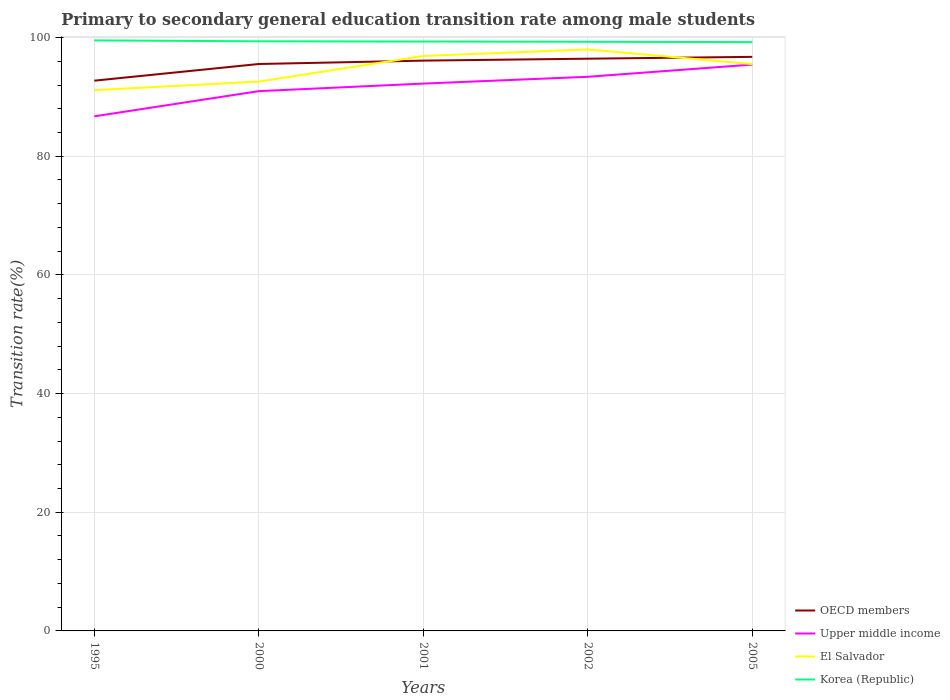How many different coloured lines are there?
Provide a succinct answer. 4. Does the line corresponding to Korea (Republic) intersect with the line corresponding to Upper middle income?
Ensure brevity in your answer.  No. Across all years, what is the maximum transition rate in OECD members?
Provide a short and direct response. 92.74. In which year was the transition rate in OECD members maximum?
Offer a terse response. 1995. What is the total transition rate in El Salvador in the graph?
Your answer should be compact. -5.42. What is the difference between the highest and the second highest transition rate in Korea (Republic)?
Offer a terse response. 0.29. What is the difference between two consecutive major ticks on the Y-axis?
Provide a short and direct response. 20. Are the values on the major ticks of Y-axis written in scientific E-notation?
Your answer should be very brief. No. Does the graph contain any zero values?
Keep it short and to the point. No. Does the graph contain grids?
Your response must be concise. Yes. Where does the legend appear in the graph?
Provide a succinct answer. Bottom right. How are the legend labels stacked?
Make the answer very short. Vertical. What is the title of the graph?
Ensure brevity in your answer.  Primary to secondary general education transition rate among male students. Does "Myanmar" appear as one of the legend labels in the graph?
Offer a very short reply. No. What is the label or title of the Y-axis?
Make the answer very short. Transition rate(%). What is the Transition rate(%) in OECD members in 1995?
Your response must be concise. 92.74. What is the Transition rate(%) of Upper middle income in 1995?
Your answer should be very brief. 86.73. What is the Transition rate(%) in El Salvador in 1995?
Keep it short and to the point. 91.15. What is the Transition rate(%) in Korea (Republic) in 1995?
Make the answer very short. 99.53. What is the Transition rate(%) in OECD members in 2000?
Offer a terse response. 95.55. What is the Transition rate(%) of Upper middle income in 2000?
Your answer should be compact. 90.97. What is the Transition rate(%) of El Salvador in 2000?
Give a very brief answer. 92.58. What is the Transition rate(%) of Korea (Republic) in 2000?
Make the answer very short. 99.37. What is the Transition rate(%) in OECD members in 2001?
Provide a short and direct response. 96.12. What is the Transition rate(%) of Upper middle income in 2001?
Ensure brevity in your answer.  92.25. What is the Transition rate(%) in El Salvador in 2001?
Offer a very short reply. 96.9. What is the Transition rate(%) of Korea (Republic) in 2001?
Make the answer very short. 99.33. What is the Transition rate(%) of OECD members in 2002?
Your answer should be compact. 96.44. What is the Transition rate(%) in Upper middle income in 2002?
Keep it short and to the point. 93.39. What is the Transition rate(%) in El Salvador in 2002?
Provide a succinct answer. 98. What is the Transition rate(%) of Korea (Republic) in 2002?
Provide a succinct answer. 99.3. What is the Transition rate(%) of OECD members in 2005?
Your answer should be compact. 96.75. What is the Transition rate(%) of Upper middle income in 2005?
Offer a terse response. 95.45. What is the Transition rate(%) of El Salvador in 2005?
Your response must be concise. 95.53. What is the Transition rate(%) in Korea (Republic) in 2005?
Provide a short and direct response. 99.24. Across all years, what is the maximum Transition rate(%) of OECD members?
Keep it short and to the point. 96.75. Across all years, what is the maximum Transition rate(%) in Upper middle income?
Your response must be concise. 95.45. Across all years, what is the maximum Transition rate(%) of El Salvador?
Make the answer very short. 98. Across all years, what is the maximum Transition rate(%) in Korea (Republic)?
Offer a terse response. 99.53. Across all years, what is the minimum Transition rate(%) of OECD members?
Offer a terse response. 92.74. Across all years, what is the minimum Transition rate(%) in Upper middle income?
Provide a succinct answer. 86.73. Across all years, what is the minimum Transition rate(%) in El Salvador?
Your answer should be compact. 91.15. Across all years, what is the minimum Transition rate(%) of Korea (Republic)?
Offer a terse response. 99.24. What is the total Transition rate(%) of OECD members in the graph?
Provide a short and direct response. 477.6. What is the total Transition rate(%) in Upper middle income in the graph?
Ensure brevity in your answer.  458.79. What is the total Transition rate(%) of El Salvador in the graph?
Provide a succinct answer. 474.16. What is the total Transition rate(%) in Korea (Republic) in the graph?
Make the answer very short. 496.77. What is the difference between the Transition rate(%) in OECD members in 1995 and that in 2000?
Provide a short and direct response. -2.81. What is the difference between the Transition rate(%) in Upper middle income in 1995 and that in 2000?
Give a very brief answer. -4.25. What is the difference between the Transition rate(%) of El Salvador in 1995 and that in 2000?
Keep it short and to the point. -1.44. What is the difference between the Transition rate(%) in Korea (Republic) in 1995 and that in 2000?
Offer a terse response. 0.16. What is the difference between the Transition rate(%) in OECD members in 1995 and that in 2001?
Make the answer very short. -3.38. What is the difference between the Transition rate(%) of Upper middle income in 1995 and that in 2001?
Your answer should be compact. -5.52. What is the difference between the Transition rate(%) in El Salvador in 1995 and that in 2001?
Keep it short and to the point. -5.75. What is the difference between the Transition rate(%) of Korea (Republic) in 1995 and that in 2001?
Make the answer very short. 0.2. What is the difference between the Transition rate(%) in OECD members in 1995 and that in 2002?
Give a very brief answer. -3.71. What is the difference between the Transition rate(%) in Upper middle income in 1995 and that in 2002?
Give a very brief answer. -6.66. What is the difference between the Transition rate(%) in El Salvador in 1995 and that in 2002?
Give a very brief answer. -6.86. What is the difference between the Transition rate(%) of Korea (Republic) in 1995 and that in 2002?
Your answer should be compact. 0.24. What is the difference between the Transition rate(%) of OECD members in 1995 and that in 2005?
Give a very brief answer. -4.01. What is the difference between the Transition rate(%) in Upper middle income in 1995 and that in 2005?
Make the answer very short. -8.72. What is the difference between the Transition rate(%) in El Salvador in 1995 and that in 2005?
Make the answer very short. -4.38. What is the difference between the Transition rate(%) in Korea (Republic) in 1995 and that in 2005?
Keep it short and to the point. 0.29. What is the difference between the Transition rate(%) in OECD members in 2000 and that in 2001?
Ensure brevity in your answer.  -0.57. What is the difference between the Transition rate(%) in Upper middle income in 2000 and that in 2001?
Your answer should be very brief. -1.27. What is the difference between the Transition rate(%) of El Salvador in 2000 and that in 2001?
Keep it short and to the point. -4.31. What is the difference between the Transition rate(%) of Korea (Republic) in 2000 and that in 2001?
Your response must be concise. 0.04. What is the difference between the Transition rate(%) in OECD members in 2000 and that in 2002?
Offer a very short reply. -0.89. What is the difference between the Transition rate(%) of Upper middle income in 2000 and that in 2002?
Ensure brevity in your answer.  -2.42. What is the difference between the Transition rate(%) of El Salvador in 2000 and that in 2002?
Provide a succinct answer. -5.42. What is the difference between the Transition rate(%) in Korea (Republic) in 2000 and that in 2002?
Make the answer very short. 0.08. What is the difference between the Transition rate(%) in OECD members in 2000 and that in 2005?
Your answer should be compact. -1.2. What is the difference between the Transition rate(%) in Upper middle income in 2000 and that in 2005?
Make the answer very short. -4.48. What is the difference between the Transition rate(%) of El Salvador in 2000 and that in 2005?
Provide a short and direct response. -2.94. What is the difference between the Transition rate(%) of Korea (Republic) in 2000 and that in 2005?
Your answer should be compact. 0.14. What is the difference between the Transition rate(%) in OECD members in 2001 and that in 2002?
Keep it short and to the point. -0.33. What is the difference between the Transition rate(%) of Upper middle income in 2001 and that in 2002?
Offer a terse response. -1.14. What is the difference between the Transition rate(%) of El Salvador in 2001 and that in 2002?
Your answer should be very brief. -1.1. What is the difference between the Transition rate(%) in Korea (Republic) in 2001 and that in 2002?
Make the answer very short. 0.04. What is the difference between the Transition rate(%) of OECD members in 2001 and that in 2005?
Keep it short and to the point. -0.63. What is the difference between the Transition rate(%) in Upper middle income in 2001 and that in 2005?
Ensure brevity in your answer.  -3.21. What is the difference between the Transition rate(%) in El Salvador in 2001 and that in 2005?
Keep it short and to the point. 1.37. What is the difference between the Transition rate(%) in Korea (Republic) in 2001 and that in 2005?
Provide a short and direct response. 0.1. What is the difference between the Transition rate(%) of OECD members in 2002 and that in 2005?
Your answer should be compact. -0.31. What is the difference between the Transition rate(%) in Upper middle income in 2002 and that in 2005?
Make the answer very short. -2.06. What is the difference between the Transition rate(%) of El Salvador in 2002 and that in 2005?
Offer a very short reply. 2.47. What is the difference between the Transition rate(%) of Korea (Republic) in 2002 and that in 2005?
Offer a terse response. 0.06. What is the difference between the Transition rate(%) of OECD members in 1995 and the Transition rate(%) of Upper middle income in 2000?
Keep it short and to the point. 1.77. What is the difference between the Transition rate(%) in OECD members in 1995 and the Transition rate(%) in El Salvador in 2000?
Provide a succinct answer. 0.15. What is the difference between the Transition rate(%) in OECD members in 1995 and the Transition rate(%) in Korea (Republic) in 2000?
Your answer should be very brief. -6.63. What is the difference between the Transition rate(%) in Upper middle income in 1995 and the Transition rate(%) in El Salvador in 2000?
Provide a succinct answer. -5.86. What is the difference between the Transition rate(%) in Upper middle income in 1995 and the Transition rate(%) in Korea (Republic) in 2000?
Ensure brevity in your answer.  -12.65. What is the difference between the Transition rate(%) in El Salvador in 1995 and the Transition rate(%) in Korea (Republic) in 2000?
Keep it short and to the point. -8.23. What is the difference between the Transition rate(%) in OECD members in 1995 and the Transition rate(%) in Upper middle income in 2001?
Provide a succinct answer. 0.49. What is the difference between the Transition rate(%) of OECD members in 1995 and the Transition rate(%) of El Salvador in 2001?
Make the answer very short. -4.16. What is the difference between the Transition rate(%) in OECD members in 1995 and the Transition rate(%) in Korea (Republic) in 2001?
Offer a terse response. -6.6. What is the difference between the Transition rate(%) in Upper middle income in 1995 and the Transition rate(%) in El Salvador in 2001?
Offer a very short reply. -10.17. What is the difference between the Transition rate(%) in Upper middle income in 1995 and the Transition rate(%) in Korea (Republic) in 2001?
Ensure brevity in your answer.  -12.61. What is the difference between the Transition rate(%) in El Salvador in 1995 and the Transition rate(%) in Korea (Republic) in 2001?
Provide a succinct answer. -8.19. What is the difference between the Transition rate(%) in OECD members in 1995 and the Transition rate(%) in Upper middle income in 2002?
Offer a terse response. -0.65. What is the difference between the Transition rate(%) of OECD members in 1995 and the Transition rate(%) of El Salvador in 2002?
Ensure brevity in your answer.  -5.26. What is the difference between the Transition rate(%) in OECD members in 1995 and the Transition rate(%) in Korea (Republic) in 2002?
Provide a succinct answer. -6.56. What is the difference between the Transition rate(%) in Upper middle income in 1995 and the Transition rate(%) in El Salvador in 2002?
Offer a terse response. -11.28. What is the difference between the Transition rate(%) of Upper middle income in 1995 and the Transition rate(%) of Korea (Republic) in 2002?
Ensure brevity in your answer.  -12.57. What is the difference between the Transition rate(%) in El Salvador in 1995 and the Transition rate(%) in Korea (Republic) in 2002?
Your answer should be very brief. -8.15. What is the difference between the Transition rate(%) in OECD members in 1995 and the Transition rate(%) in Upper middle income in 2005?
Your answer should be compact. -2.71. What is the difference between the Transition rate(%) in OECD members in 1995 and the Transition rate(%) in El Salvador in 2005?
Ensure brevity in your answer.  -2.79. What is the difference between the Transition rate(%) of OECD members in 1995 and the Transition rate(%) of Korea (Republic) in 2005?
Make the answer very short. -6.5. What is the difference between the Transition rate(%) in Upper middle income in 1995 and the Transition rate(%) in El Salvador in 2005?
Keep it short and to the point. -8.8. What is the difference between the Transition rate(%) of Upper middle income in 1995 and the Transition rate(%) of Korea (Republic) in 2005?
Ensure brevity in your answer.  -12.51. What is the difference between the Transition rate(%) of El Salvador in 1995 and the Transition rate(%) of Korea (Republic) in 2005?
Provide a short and direct response. -8.09. What is the difference between the Transition rate(%) in OECD members in 2000 and the Transition rate(%) in Upper middle income in 2001?
Ensure brevity in your answer.  3.3. What is the difference between the Transition rate(%) in OECD members in 2000 and the Transition rate(%) in El Salvador in 2001?
Your response must be concise. -1.35. What is the difference between the Transition rate(%) of OECD members in 2000 and the Transition rate(%) of Korea (Republic) in 2001?
Offer a very short reply. -3.79. What is the difference between the Transition rate(%) of Upper middle income in 2000 and the Transition rate(%) of El Salvador in 2001?
Give a very brief answer. -5.93. What is the difference between the Transition rate(%) of Upper middle income in 2000 and the Transition rate(%) of Korea (Republic) in 2001?
Ensure brevity in your answer.  -8.36. What is the difference between the Transition rate(%) of El Salvador in 2000 and the Transition rate(%) of Korea (Republic) in 2001?
Provide a succinct answer. -6.75. What is the difference between the Transition rate(%) of OECD members in 2000 and the Transition rate(%) of Upper middle income in 2002?
Provide a succinct answer. 2.16. What is the difference between the Transition rate(%) in OECD members in 2000 and the Transition rate(%) in El Salvador in 2002?
Offer a very short reply. -2.45. What is the difference between the Transition rate(%) in OECD members in 2000 and the Transition rate(%) in Korea (Republic) in 2002?
Your answer should be very brief. -3.75. What is the difference between the Transition rate(%) of Upper middle income in 2000 and the Transition rate(%) of El Salvador in 2002?
Your response must be concise. -7.03. What is the difference between the Transition rate(%) of Upper middle income in 2000 and the Transition rate(%) of Korea (Republic) in 2002?
Ensure brevity in your answer.  -8.32. What is the difference between the Transition rate(%) of El Salvador in 2000 and the Transition rate(%) of Korea (Republic) in 2002?
Make the answer very short. -6.71. What is the difference between the Transition rate(%) in OECD members in 2000 and the Transition rate(%) in Upper middle income in 2005?
Ensure brevity in your answer.  0.1. What is the difference between the Transition rate(%) in OECD members in 2000 and the Transition rate(%) in El Salvador in 2005?
Ensure brevity in your answer.  0.02. What is the difference between the Transition rate(%) in OECD members in 2000 and the Transition rate(%) in Korea (Republic) in 2005?
Your response must be concise. -3.69. What is the difference between the Transition rate(%) of Upper middle income in 2000 and the Transition rate(%) of El Salvador in 2005?
Your response must be concise. -4.56. What is the difference between the Transition rate(%) in Upper middle income in 2000 and the Transition rate(%) in Korea (Republic) in 2005?
Keep it short and to the point. -8.26. What is the difference between the Transition rate(%) in El Salvador in 2000 and the Transition rate(%) in Korea (Republic) in 2005?
Offer a terse response. -6.65. What is the difference between the Transition rate(%) of OECD members in 2001 and the Transition rate(%) of Upper middle income in 2002?
Make the answer very short. 2.73. What is the difference between the Transition rate(%) of OECD members in 2001 and the Transition rate(%) of El Salvador in 2002?
Offer a terse response. -1.89. What is the difference between the Transition rate(%) in OECD members in 2001 and the Transition rate(%) in Korea (Republic) in 2002?
Offer a terse response. -3.18. What is the difference between the Transition rate(%) of Upper middle income in 2001 and the Transition rate(%) of El Salvador in 2002?
Provide a succinct answer. -5.76. What is the difference between the Transition rate(%) of Upper middle income in 2001 and the Transition rate(%) of Korea (Republic) in 2002?
Provide a short and direct response. -7.05. What is the difference between the Transition rate(%) in El Salvador in 2001 and the Transition rate(%) in Korea (Republic) in 2002?
Keep it short and to the point. -2.4. What is the difference between the Transition rate(%) of OECD members in 2001 and the Transition rate(%) of Upper middle income in 2005?
Your answer should be compact. 0.67. What is the difference between the Transition rate(%) in OECD members in 2001 and the Transition rate(%) in El Salvador in 2005?
Make the answer very short. 0.59. What is the difference between the Transition rate(%) in OECD members in 2001 and the Transition rate(%) in Korea (Republic) in 2005?
Give a very brief answer. -3.12. What is the difference between the Transition rate(%) in Upper middle income in 2001 and the Transition rate(%) in El Salvador in 2005?
Keep it short and to the point. -3.28. What is the difference between the Transition rate(%) in Upper middle income in 2001 and the Transition rate(%) in Korea (Republic) in 2005?
Provide a succinct answer. -6.99. What is the difference between the Transition rate(%) of El Salvador in 2001 and the Transition rate(%) of Korea (Republic) in 2005?
Offer a very short reply. -2.34. What is the difference between the Transition rate(%) in OECD members in 2002 and the Transition rate(%) in El Salvador in 2005?
Give a very brief answer. 0.91. What is the difference between the Transition rate(%) in OECD members in 2002 and the Transition rate(%) in Korea (Republic) in 2005?
Your answer should be compact. -2.79. What is the difference between the Transition rate(%) of Upper middle income in 2002 and the Transition rate(%) of El Salvador in 2005?
Your answer should be compact. -2.14. What is the difference between the Transition rate(%) in Upper middle income in 2002 and the Transition rate(%) in Korea (Republic) in 2005?
Offer a terse response. -5.85. What is the difference between the Transition rate(%) of El Salvador in 2002 and the Transition rate(%) of Korea (Republic) in 2005?
Provide a short and direct response. -1.23. What is the average Transition rate(%) of OECD members per year?
Your answer should be compact. 95.52. What is the average Transition rate(%) of Upper middle income per year?
Provide a short and direct response. 91.76. What is the average Transition rate(%) of El Salvador per year?
Offer a very short reply. 94.83. What is the average Transition rate(%) in Korea (Republic) per year?
Make the answer very short. 99.35. In the year 1995, what is the difference between the Transition rate(%) in OECD members and Transition rate(%) in Upper middle income?
Keep it short and to the point. 6.01. In the year 1995, what is the difference between the Transition rate(%) of OECD members and Transition rate(%) of El Salvador?
Ensure brevity in your answer.  1.59. In the year 1995, what is the difference between the Transition rate(%) in OECD members and Transition rate(%) in Korea (Republic)?
Provide a succinct answer. -6.79. In the year 1995, what is the difference between the Transition rate(%) in Upper middle income and Transition rate(%) in El Salvador?
Make the answer very short. -4.42. In the year 1995, what is the difference between the Transition rate(%) in Upper middle income and Transition rate(%) in Korea (Republic)?
Keep it short and to the point. -12.8. In the year 1995, what is the difference between the Transition rate(%) in El Salvador and Transition rate(%) in Korea (Republic)?
Provide a short and direct response. -8.38. In the year 2000, what is the difference between the Transition rate(%) of OECD members and Transition rate(%) of Upper middle income?
Provide a short and direct response. 4.58. In the year 2000, what is the difference between the Transition rate(%) of OECD members and Transition rate(%) of El Salvador?
Offer a terse response. 2.96. In the year 2000, what is the difference between the Transition rate(%) of OECD members and Transition rate(%) of Korea (Republic)?
Offer a terse response. -3.82. In the year 2000, what is the difference between the Transition rate(%) of Upper middle income and Transition rate(%) of El Salvador?
Keep it short and to the point. -1.61. In the year 2000, what is the difference between the Transition rate(%) in Upper middle income and Transition rate(%) in Korea (Republic)?
Give a very brief answer. -8.4. In the year 2000, what is the difference between the Transition rate(%) in El Salvador and Transition rate(%) in Korea (Republic)?
Your answer should be very brief. -6.79. In the year 2001, what is the difference between the Transition rate(%) in OECD members and Transition rate(%) in Upper middle income?
Ensure brevity in your answer.  3.87. In the year 2001, what is the difference between the Transition rate(%) of OECD members and Transition rate(%) of El Salvador?
Provide a short and direct response. -0.78. In the year 2001, what is the difference between the Transition rate(%) of OECD members and Transition rate(%) of Korea (Republic)?
Provide a short and direct response. -3.22. In the year 2001, what is the difference between the Transition rate(%) of Upper middle income and Transition rate(%) of El Salvador?
Offer a very short reply. -4.65. In the year 2001, what is the difference between the Transition rate(%) in Upper middle income and Transition rate(%) in Korea (Republic)?
Your answer should be very brief. -7.09. In the year 2001, what is the difference between the Transition rate(%) in El Salvador and Transition rate(%) in Korea (Republic)?
Your answer should be very brief. -2.44. In the year 2002, what is the difference between the Transition rate(%) in OECD members and Transition rate(%) in Upper middle income?
Offer a terse response. 3.05. In the year 2002, what is the difference between the Transition rate(%) in OECD members and Transition rate(%) in El Salvador?
Give a very brief answer. -1.56. In the year 2002, what is the difference between the Transition rate(%) of OECD members and Transition rate(%) of Korea (Republic)?
Offer a very short reply. -2.85. In the year 2002, what is the difference between the Transition rate(%) of Upper middle income and Transition rate(%) of El Salvador?
Provide a short and direct response. -4.61. In the year 2002, what is the difference between the Transition rate(%) in Upper middle income and Transition rate(%) in Korea (Republic)?
Provide a short and direct response. -5.9. In the year 2002, what is the difference between the Transition rate(%) of El Salvador and Transition rate(%) of Korea (Republic)?
Your response must be concise. -1.29. In the year 2005, what is the difference between the Transition rate(%) of OECD members and Transition rate(%) of Upper middle income?
Ensure brevity in your answer.  1.3. In the year 2005, what is the difference between the Transition rate(%) of OECD members and Transition rate(%) of El Salvador?
Provide a succinct answer. 1.22. In the year 2005, what is the difference between the Transition rate(%) in OECD members and Transition rate(%) in Korea (Republic)?
Your answer should be very brief. -2.49. In the year 2005, what is the difference between the Transition rate(%) in Upper middle income and Transition rate(%) in El Salvador?
Offer a very short reply. -0.08. In the year 2005, what is the difference between the Transition rate(%) in Upper middle income and Transition rate(%) in Korea (Republic)?
Keep it short and to the point. -3.79. In the year 2005, what is the difference between the Transition rate(%) of El Salvador and Transition rate(%) of Korea (Republic)?
Provide a short and direct response. -3.71. What is the ratio of the Transition rate(%) of OECD members in 1995 to that in 2000?
Provide a succinct answer. 0.97. What is the ratio of the Transition rate(%) of Upper middle income in 1995 to that in 2000?
Your answer should be compact. 0.95. What is the ratio of the Transition rate(%) of El Salvador in 1995 to that in 2000?
Your answer should be very brief. 0.98. What is the ratio of the Transition rate(%) of Korea (Republic) in 1995 to that in 2000?
Make the answer very short. 1. What is the ratio of the Transition rate(%) in OECD members in 1995 to that in 2001?
Offer a terse response. 0.96. What is the ratio of the Transition rate(%) in Upper middle income in 1995 to that in 2001?
Make the answer very short. 0.94. What is the ratio of the Transition rate(%) of El Salvador in 1995 to that in 2001?
Your response must be concise. 0.94. What is the ratio of the Transition rate(%) in OECD members in 1995 to that in 2002?
Provide a short and direct response. 0.96. What is the ratio of the Transition rate(%) in El Salvador in 1995 to that in 2002?
Your answer should be very brief. 0.93. What is the ratio of the Transition rate(%) of Korea (Republic) in 1995 to that in 2002?
Your response must be concise. 1. What is the ratio of the Transition rate(%) of OECD members in 1995 to that in 2005?
Give a very brief answer. 0.96. What is the ratio of the Transition rate(%) of Upper middle income in 1995 to that in 2005?
Give a very brief answer. 0.91. What is the ratio of the Transition rate(%) in El Salvador in 1995 to that in 2005?
Offer a terse response. 0.95. What is the ratio of the Transition rate(%) of Korea (Republic) in 1995 to that in 2005?
Keep it short and to the point. 1. What is the ratio of the Transition rate(%) of OECD members in 2000 to that in 2001?
Your answer should be very brief. 0.99. What is the ratio of the Transition rate(%) of Upper middle income in 2000 to that in 2001?
Provide a succinct answer. 0.99. What is the ratio of the Transition rate(%) of El Salvador in 2000 to that in 2001?
Give a very brief answer. 0.96. What is the ratio of the Transition rate(%) in Upper middle income in 2000 to that in 2002?
Your answer should be very brief. 0.97. What is the ratio of the Transition rate(%) in El Salvador in 2000 to that in 2002?
Your answer should be very brief. 0.94. What is the ratio of the Transition rate(%) of Korea (Republic) in 2000 to that in 2002?
Ensure brevity in your answer.  1. What is the ratio of the Transition rate(%) of OECD members in 2000 to that in 2005?
Offer a terse response. 0.99. What is the ratio of the Transition rate(%) in Upper middle income in 2000 to that in 2005?
Offer a terse response. 0.95. What is the ratio of the Transition rate(%) of El Salvador in 2000 to that in 2005?
Provide a succinct answer. 0.97. What is the ratio of the Transition rate(%) of Upper middle income in 2001 to that in 2002?
Provide a short and direct response. 0.99. What is the ratio of the Transition rate(%) in El Salvador in 2001 to that in 2002?
Give a very brief answer. 0.99. What is the ratio of the Transition rate(%) of Upper middle income in 2001 to that in 2005?
Keep it short and to the point. 0.97. What is the ratio of the Transition rate(%) of El Salvador in 2001 to that in 2005?
Your response must be concise. 1.01. What is the ratio of the Transition rate(%) of Korea (Republic) in 2001 to that in 2005?
Ensure brevity in your answer.  1. What is the ratio of the Transition rate(%) of Upper middle income in 2002 to that in 2005?
Make the answer very short. 0.98. What is the ratio of the Transition rate(%) in El Salvador in 2002 to that in 2005?
Provide a succinct answer. 1.03. What is the difference between the highest and the second highest Transition rate(%) in OECD members?
Offer a very short reply. 0.31. What is the difference between the highest and the second highest Transition rate(%) in Upper middle income?
Your response must be concise. 2.06. What is the difference between the highest and the second highest Transition rate(%) of El Salvador?
Offer a terse response. 1.1. What is the difference between the highest and the second highest Transition rate(%) of Korea (Republic)?
Your answer should be compact. 0.16. What is the difference between the highest and the lowest Transition rate(%) in OECD members?
Ensure brevity in your answer.  4.01. What is the difference between the highest and the lowest Transition rate(%) in Upper middle income?
Keep it short and to the point. 8.72. What is the difference between the highest and the lowest Transition rate(%) of El Salvador?
Keep it short and to the point. 6.86. What is the difference between the highest and the lowest Transition rate(%) in Korea (Republic)?
Your response must be concise. 0.29. 